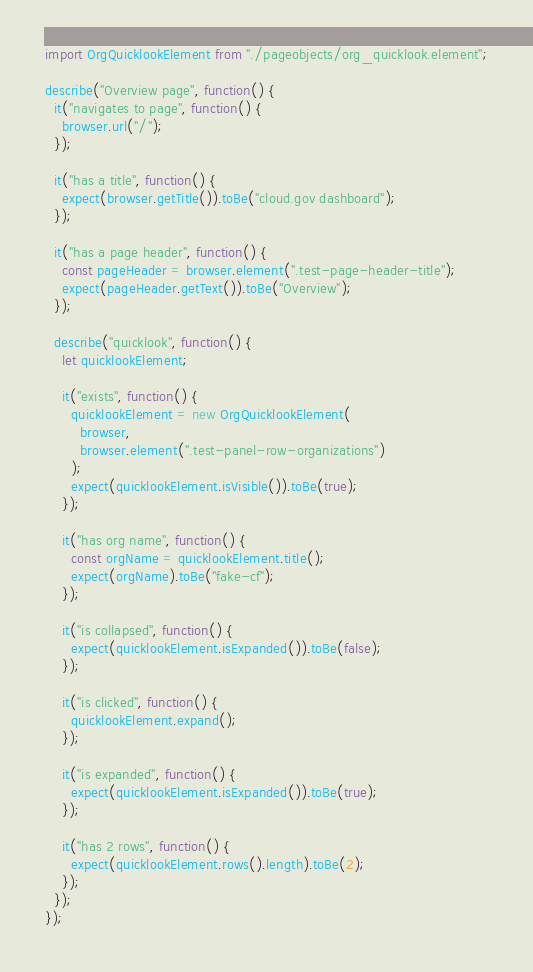<code> <loc_0><loc_0><loc_500><loc_500><_JavaScript_>import OrgQuicklookElement from "./pageobjects/org_quicklook.element";

describe("Overview page", function() {
  it("navigates to page", function() {
    browser.url("/");
  });

  it("has a title", function() {
    expect(browser.getTitle()).toBe("cloud.gov dashboard");
  });

  it("has a page header", function() {
    const pageHeader = browser.element(".test-page-header-title");
    expect(pageHeader.getText()).toBe("Overview");
  });

  describe("quicklook", function() {
    let quicklookElement;

    it("exists", function() {
      quicklookElement = new OrgQuicklookElement(
        browser,
        browser.element(".test-panel-row-organizations")
      );
      expect(quicklookElement.isVisible()).toBe(true);
    });

    it("has org name", function() {
      const orgName = quicklookElement.title();
      expect(orgName).toBe("fake-cf");
    });

    it("is collapsed", function() {
      expect(quicklookElement.isExpanded()).toBe(false);
    });

    it("is clicked", function() {
      quicklookElement.expand();
    });

    it("is expanded", function() {
      expect(quicklookElement.isExpanded()).toBe(true);
    });

    it("has 2 rows", function() {
      expect(quicklookElement.rows().length).toBe(2);
    });
  });
});
</code> 